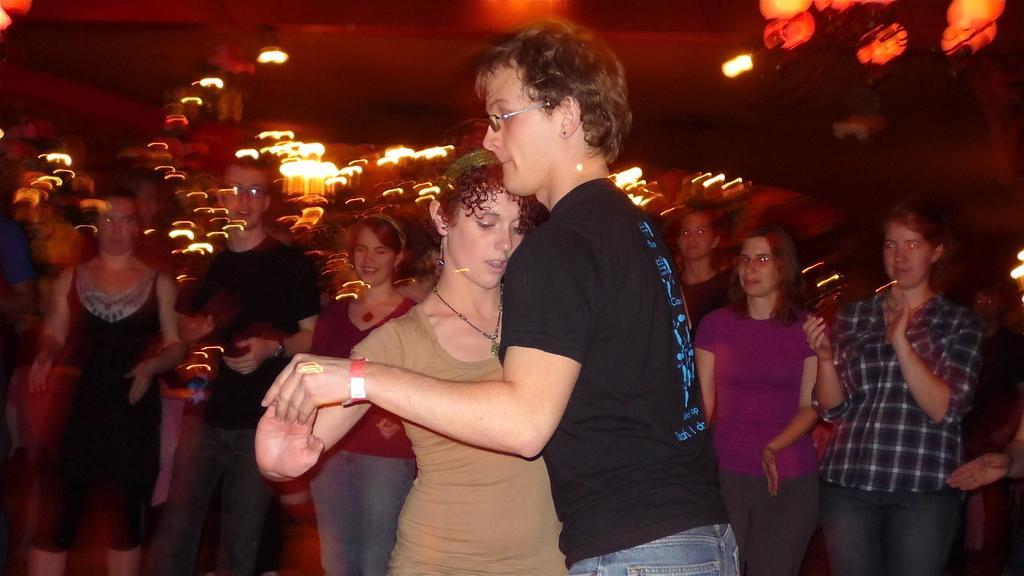Describe this image in one or two sentences. In this image we can see people. At the top of the image there is ceiling with lights. 